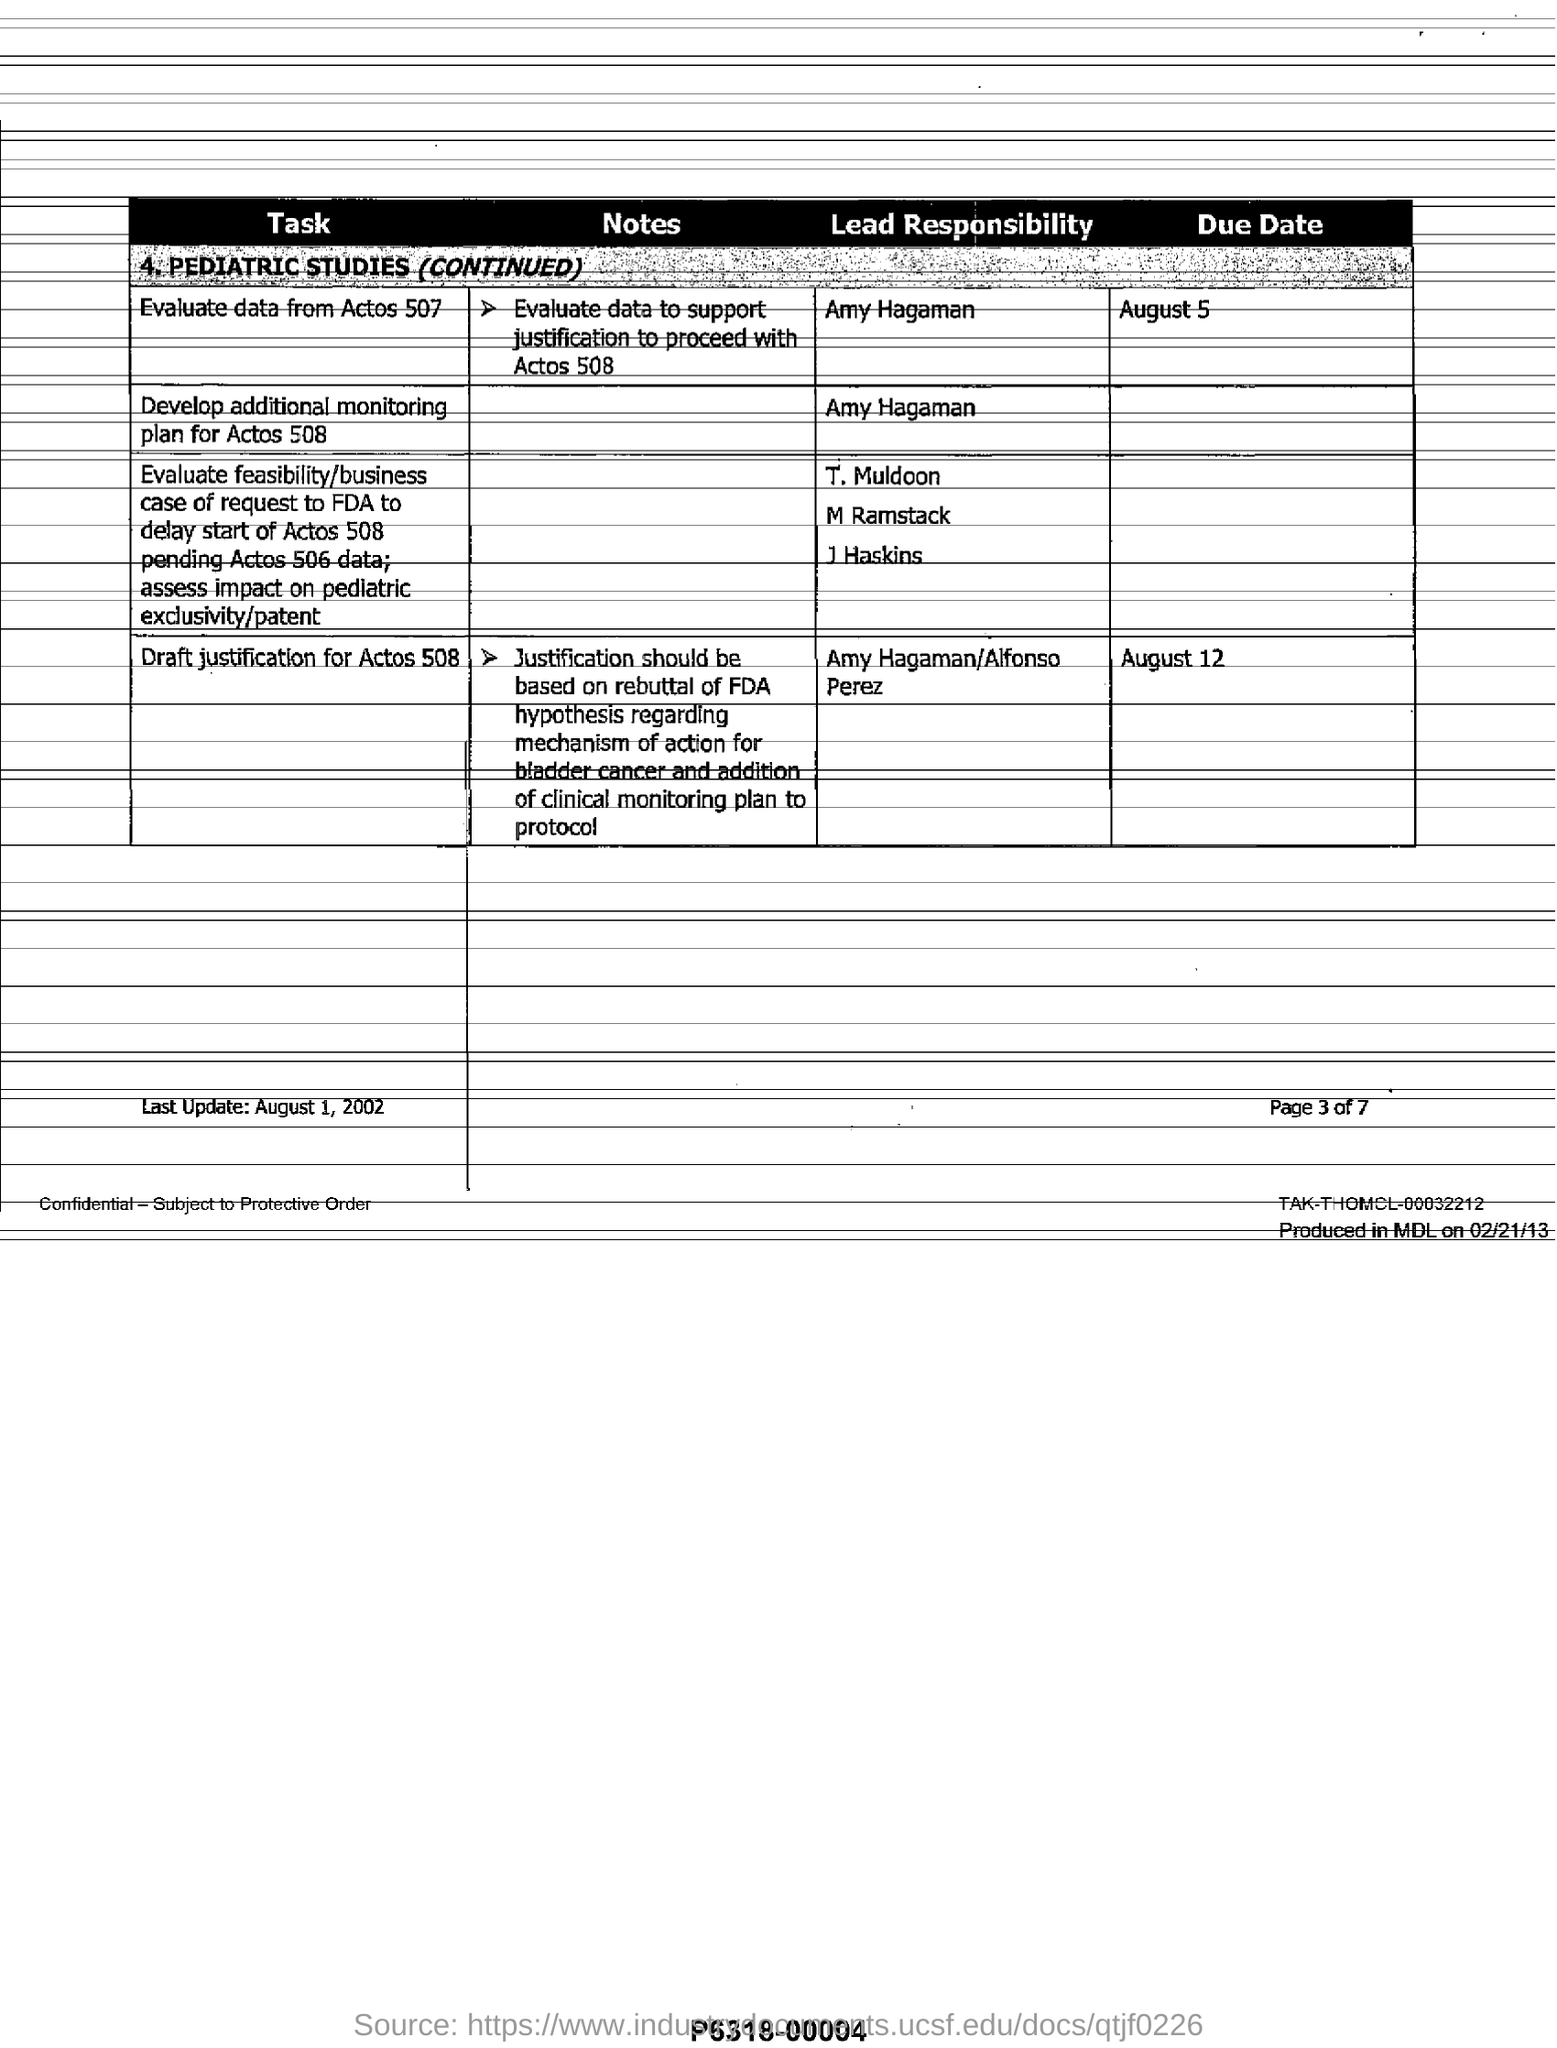What is the due date to evaluate data from actos 507?
Give a very brief answer. August 5. Who is the lead responsibility for developing additional monitoring plan for actos 508
Your response must be concise. Amy hagaman. What is the due date for "draft  justification for actos 508" ?
Offer a very short reply. August 12. When was this  last updated ?
Ensure brevity in your answer.  August 1, 2002. Who is the lead responsible person for draft justification for actos 508?
Provide a succinct answer. Amy Hagaman/Alfonso Perez. How many pages are there in total as part of this document?
Offer a terse response. 7. 